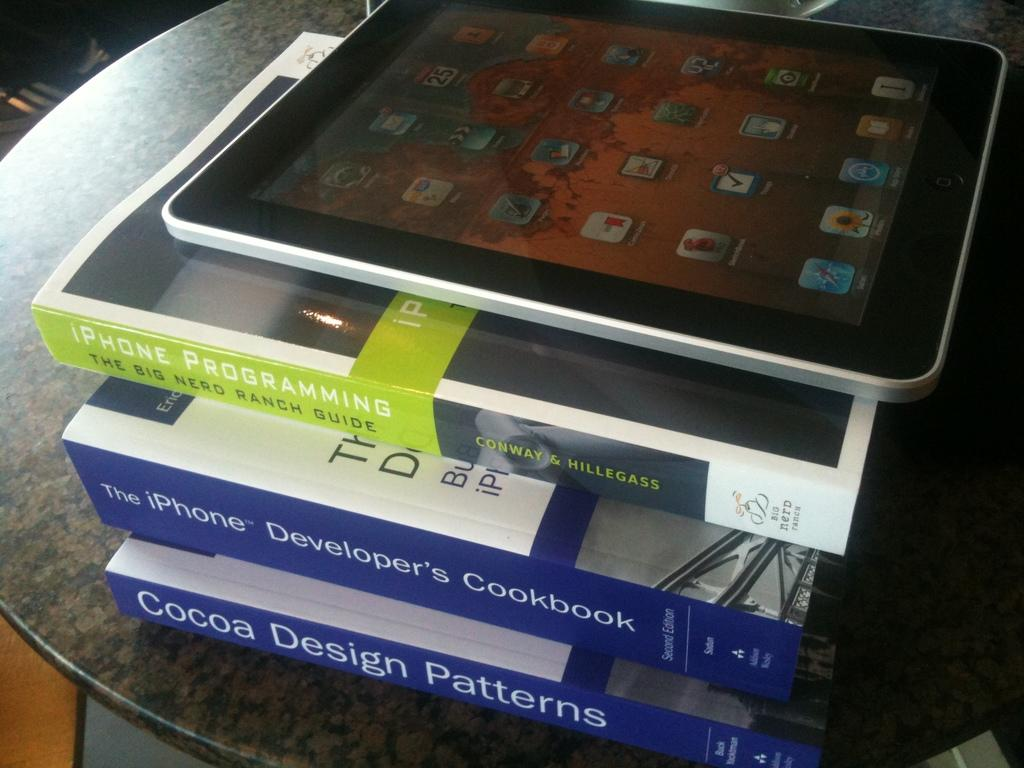<image>
Create a compact narrative representing the image presented. A tablet rests on top of a stack of books such as The iPhone's Developer's Cookbook. 